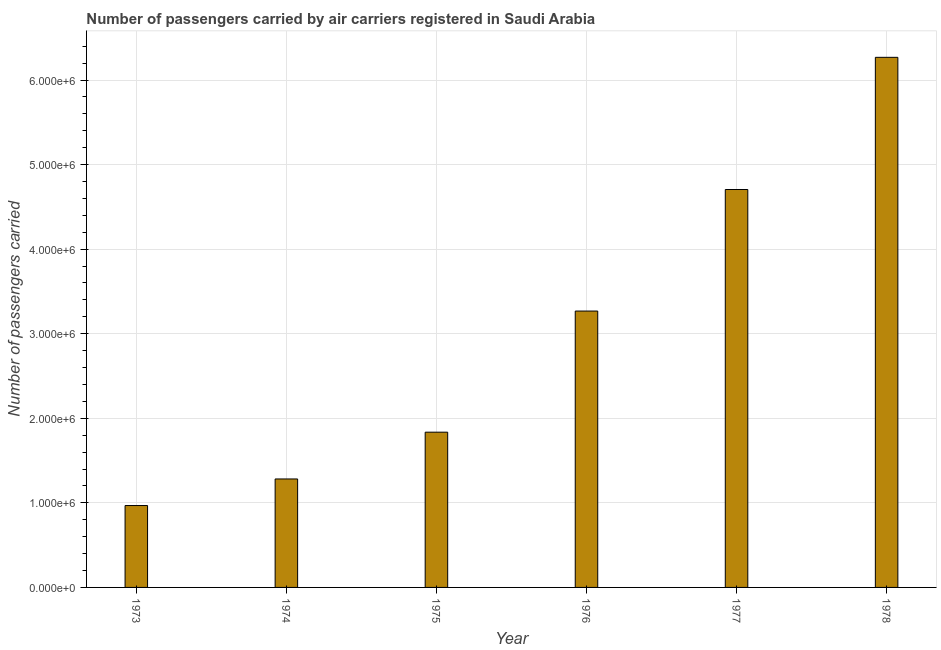Does the graph contain any zero values?
Ensure brevity in your answer.  No. Does the graph contain grids?
Keep it short and to the point. Yes. What is the title of the graph?
Offer a very short reply. Number of passengers carried by air carriers registered in Saudi Arabia. What is the label or title of the Y-axis?
Provide a short and direct response. Number of passengers carried. What is the number of passengers carried in 1973?
Provide a succinct answer. 9.68e+05. Across all years, what is the maximum number of passengers carried?
Offer a terse response. 6.27e+06. Across all years, what is the minimum number of passengers carried?
Your answer should be compact. 9.68e+05. In which year was the number of passengers carried maximum?
Provide a short and direct response. 1978. What is the sum of the number of passengers carried?
Your answer should be very brief. 1.83e+07. What is the difference between the number of passengers carried in 1973 and 1977?
Provide a short and direct response. -3.74e+06. What is the average number of passengers carried per year?
Provide a succinct answer. 3.05e+06. What is the median number of passengers carried?
Provide a short and direct response. 2.55e+06. In how many years, is the number of passengers carried greater than 4800000 ?
Keep it short and to the point. 1. Do a majority of the years between 1976 and 1978 (inclusive) have number of passengers carried greater than 6000000 ?
Your response must be concise. No. What is the ratio of the number of passengers carried in 1973 to that in 1976?
Keep it short and to the point. 0.3. Is the difference between the number of passengers carried in 1977 and 1978 greater than the difference between any two years?
Offer a very short reply. No. What is the difference between the highest and the second highest number of passengers carried?
Give a very brief answer. 1.56e+06. Is the sum of the number of passengers carried in 1973 and 1974 greater than the maximum number of passengers carried across all years?
Your answer should be compact. No. What is the difference between the highest and the lowest number of passengers carried?
Provide a succinct answer. 5.30e+06. How many bars are there?
Give a very brief answer. 6. How many years are there in the graph?
Offer a terse response. 6. Are the values on the major ticks of Y-axis written in scientific E-notation?
Provide a short and direct response. Yes. What is the Number of passengers carried in 1973?
Make the answer very short. 9.68e+05. What is the Number of passengers carried in 1974?
Offer a terse response. 1.28e+06. What is the Number of passengers carried of 1975?
Your response must be concise. 1.84e+06. What is the Number of passengers carried of 1976?
Offer a terse response. 3.27e+06. What is the Number of passengers carried of 1977?
Give a very brief answer. 4.71e+06. What is the Number of passengers carried of 1978?
Ensure brevity in your answer.  6.27e+06. What is the difference between the Number of passengers carried in 1973 and 1974?
Ensure brevity in your answer.  -3.14e+05. What is the difference between the Number of passengers carried in 1973 and 1975?
Provide a short and direct response. -8.67e+05. What is the difference between the Number of passengers carried in 1973 and 1976?
Make the answer very short. -2.30e+06. What is the difference between the Number of passengers carried in 1973 and 1977?
Your answer should be very brief. -3.74e+06. What is the difference between the Number of passengers carried in 1973 and 1978?
Ensure brevity in your answer.  -5.30e+06. What is the difference between the Number of passengers carried in 1974 and 1975?
Make the answer very short. -5.53e+05. What is the difference between the Number of passengers carried in 1974 and 1976?
Provide a short and direct response. -1.99e+06. What is the difference between the Number of passengers carried in 1974 and 1977?
Make the answer very short. -3.42e+06. What is the difference between the Number of passengers carried in 1974 and 1978?
Your response must be concise. -4.99e+06. What is the difference between the Number of passengers carried in 1975 and 1976?
Give a very brief answer. -1.43e+06. What is the difference between the Number of passengers carried in 1975 and 1977?
Make the answer very short. -2.87e+06. What is the difference between the Number of passengers carried in 1975 and 1978?
Your answer should be very brief. -4.43e+06. What is the difference between the Number of passengers carried in 1976 and 1977?
Ensure brevity in your answer.  -1.44e+06. What is the difference between the Number of passengers carried in 1976 and 1978?
Provide a short and direct response. -3.00e+06. What is the difference between the Number of passengers carried in 1977 and 1978?
Give a very brief answer. -1.56e+06. What is the ratio of the Number of passengers carried in 1973 to that in 1974?
Your answer should be very brief. 0.76. What is the ratio of the Number of passengers carried in 1973 to that in 1975?
Offer a very short reply. 0.53. What is the ratio of the Number of passengers carried in 1973 to that in 1976?
Offer a very short reply. 0.3. What is the ratio of the Number of passengers carried in 1973 to that in 1977?
Offer a very short reply. 0.21. What is the ratio of the Number of passengers carried in 1973 to that in 1978?
Keep it short and to the point. 0.15. What is the ratio of the Number of passengers carried in 1974 to that in 1975?
Provide a succinct answer. 0.7. What is the ratio of the Number of passengers carried in 1974 to that in 1976?
Make the answer very short. 0.39. What is the ratio of the Number of passengers carried in 1974 to that in 1977?
Offer a very short reply. 0.27. What is the ratio of the Number of passengers carried in 1974 to that in 1978?
Offer a very short reply. 0.2. What is the ratio of the Number of passengers carried in 1975 to that in 1976?
Give a very brief answer. 0.56. What is the ratio of the Number of passengers carried in 1975 to that in 1977?
Your answer should be very brief. 0.39. What is the ratio of the Number of passengers carried in 1975 to that in 1978?
Offer a terse response. 0.29. What is the ratio of the Number of passengers carried in 1976 to that in 1977?
Provide a succinct answer. 0.69. What is the ratio of the Number of passengers carried in 1976 to that in 1978?
Ensure brevity in your answer.  0.52. What is the ratio of the Number of passengers carried in 1977 to that in 1978?
Give a very brief answer. 0.75. 